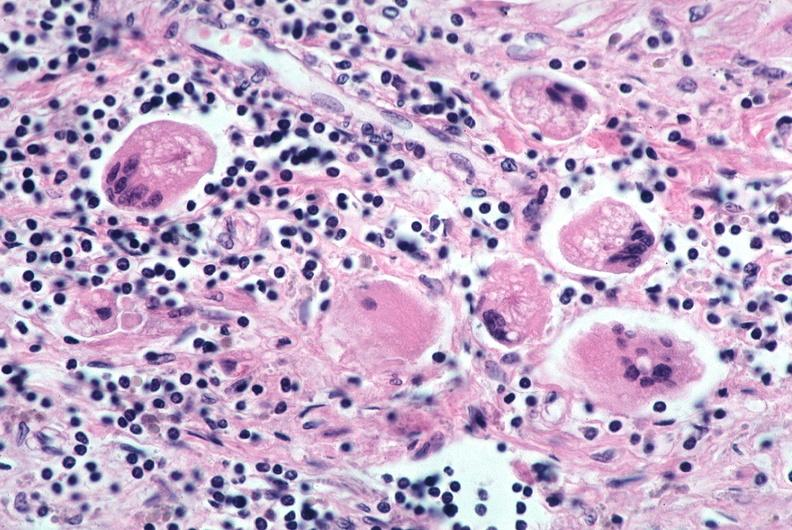does this image show lung, sarcoidosis, multinucleated giant cells with asteroid bodies?
Answer the question using a single word or phrase. Yes 